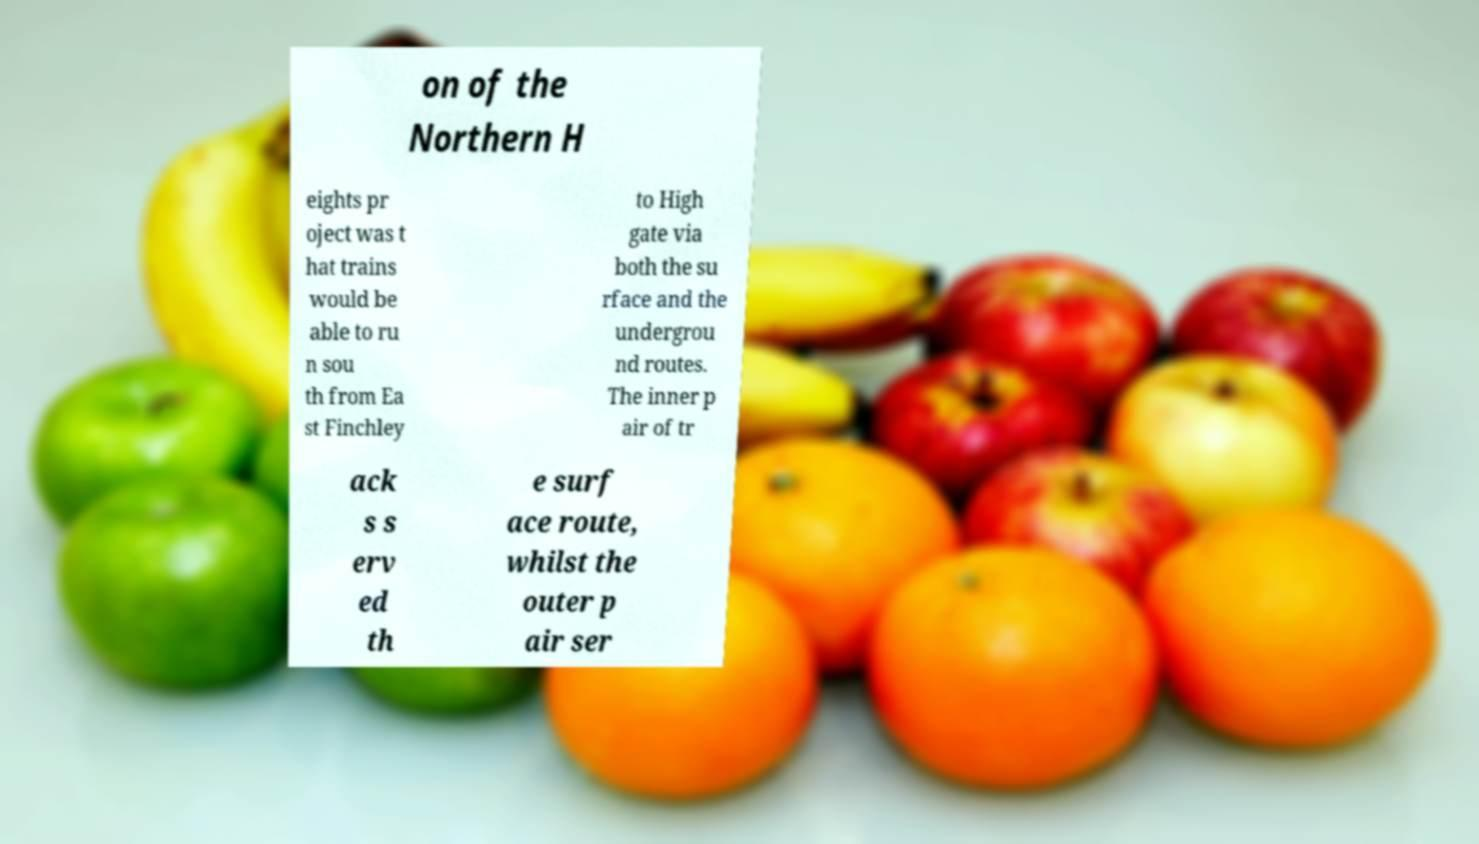Please read and relay the text visible in this image. What does it say? on of the Northern H eights pr oject was t hat trains would be able to ru n sou th from Ea st Finchley to High gate via both the su rface and the undergrou nd routes. The inner p air of tr ack s s erv ed th e surf ace route, whilst the outer p air ser 